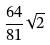Convert formula to latex. <formula><loc_0><loc_0><loc_500><loc_500>\frac { 6 4 } { 8 1 } \sqrt { 2 }</formula> 